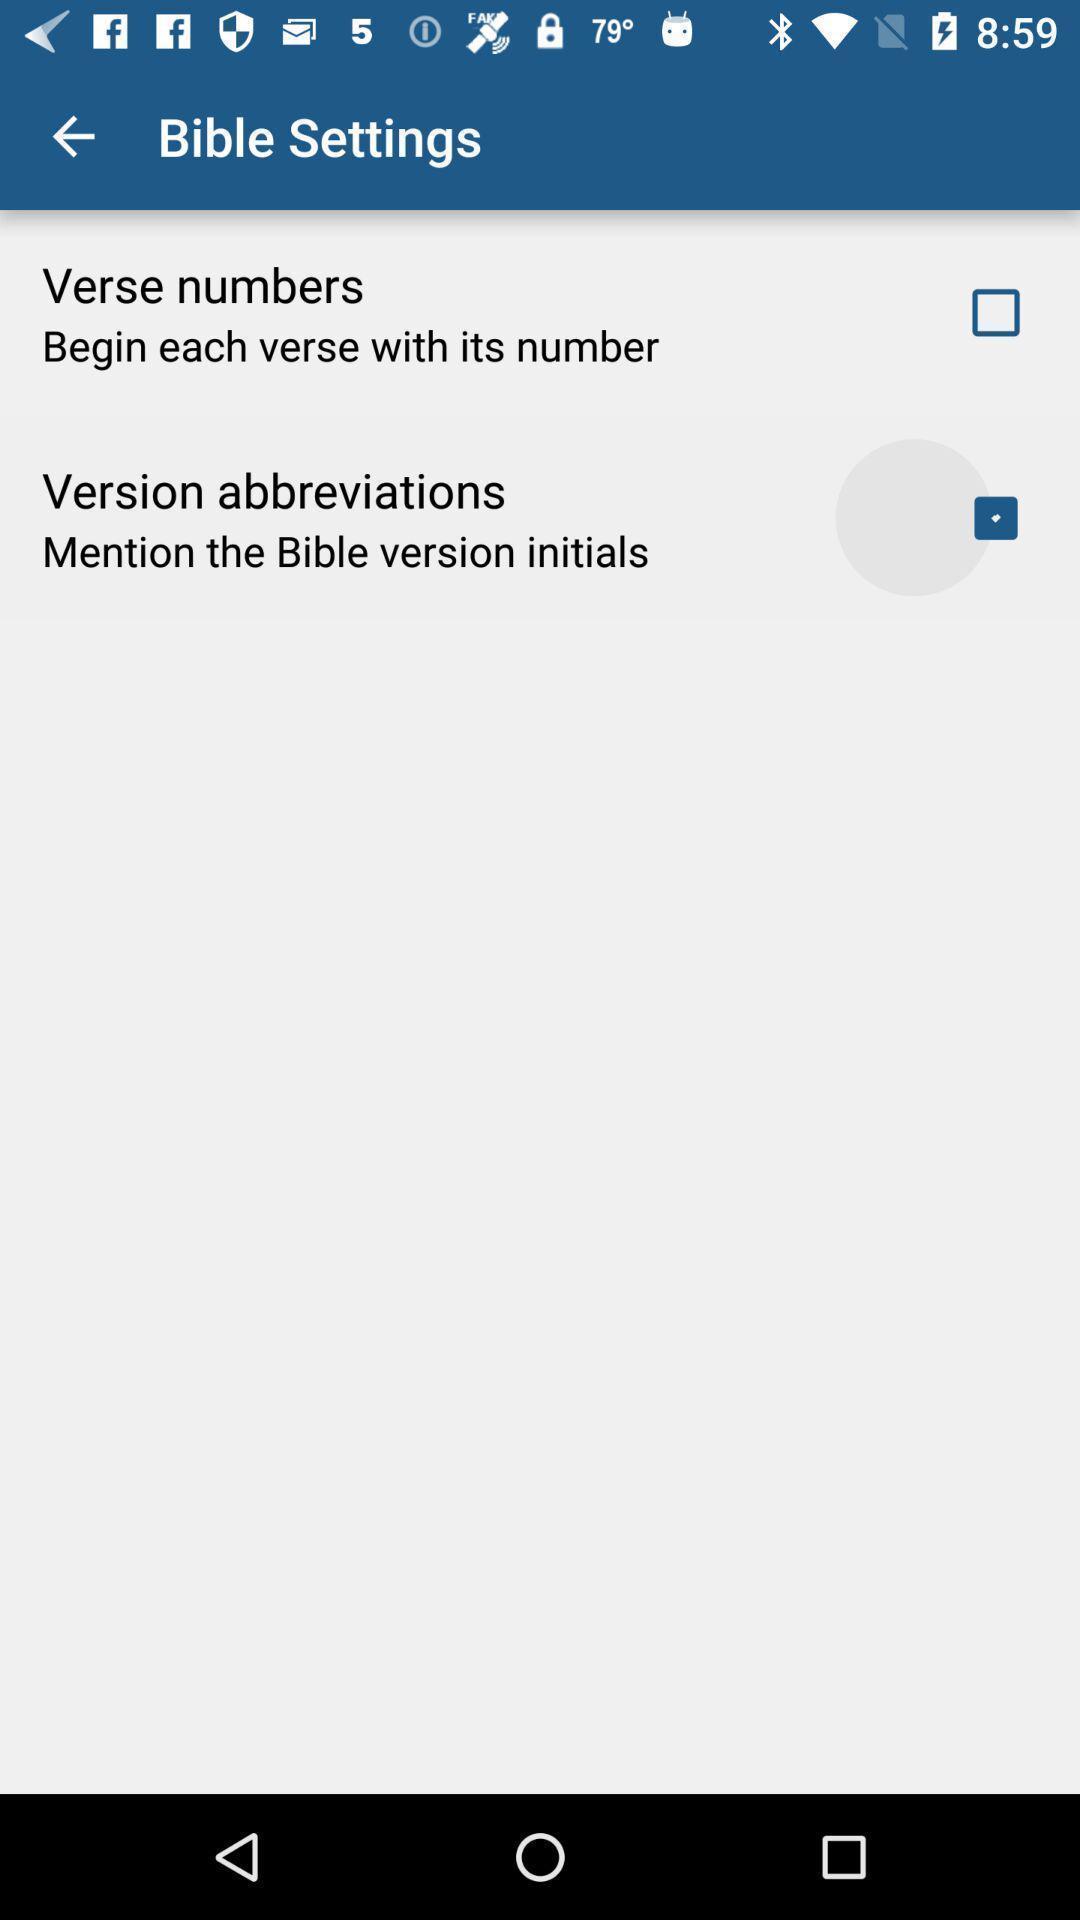Give me a narrative description of this picture. Settings interface for a religion based app. 